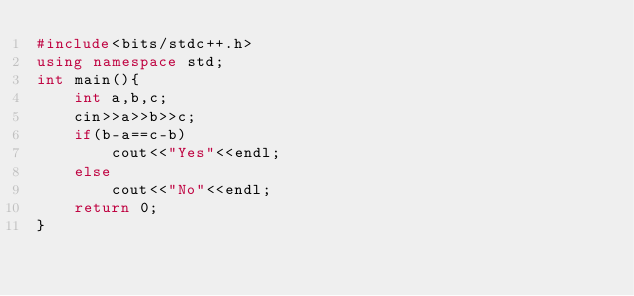Convert code to text. <code><loc_0><loc_0><loc_500><loc_500><_C++_>#include<bits/stdc++.h>
using namespace std;
int main(){
    int a,b,c;
    cin>>a>>b>>c;
    if(b-a==c-b)
        cout<<"Yes"<<endl;
    else
        cout<<"No"<<endl;
    return 0;
}</code> 